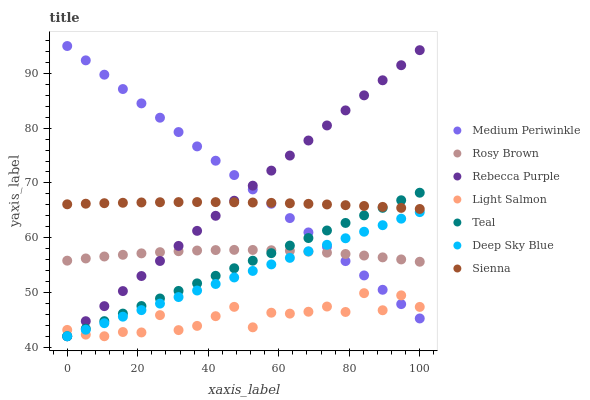Does Light Salmon have the minimum area under the curve?
Answer yes or no. Yes. Does Medium Periwinkle have the maximum area under the curve?
Answer yes or no. Yes. Does Teal have the minimum area under the curve?
Answer yes or no. No. Does Teal have the maximum area under the curve?
Answer yes or no. No. Is Deep Sky Blue the smoothest?
Answer yes or no. Yes. Is Light Salmon the roughest?
Answer yes or no. Yes. Is Teal the smoothest?
Answer yes or no. No. Is Teal the roughest?
Answer yes or no. No. Does Light Salmon have the lowest value?
Answer yes or no. Yes. Does Rosy Brown have the lowest value?
Answer yes or no. No. Does Medium Periwinkle have the highest value?
Answer yes or no. Yes. Does Teal have the highest value?
Answer yes or no. No. Is Deep Sky Blue less than Sienna?
Answer yes or no. Yes. Is Sienna greater than Light Salmon?
Answer yes or no. Yes. Does Deep Sky Blue intersect Medium Periwinkle?
Answer yes or no. Yes. Is Deep Sky Blue less than Medium Periwinkle?
Answer yes or no. No. Is Deep Sky Blue greater than Medium Periwinkle?
Answer yes or no. No. Does Deep Sky Blue intersect Sienna?
Answer yes or no. No. 